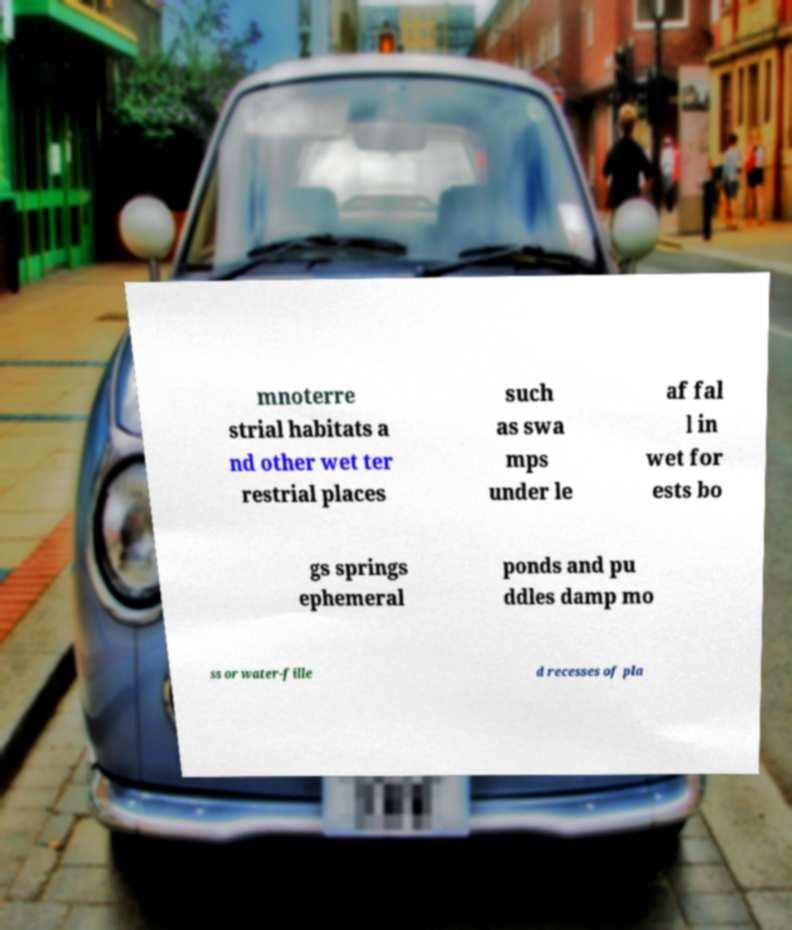Could you extract and type out the text from this image? mnoterre strial habitats a nd other wet ter restrial places such as swa mps under le af fal l in wet for ests bo gs springs ephemeral ponds and pu ddles damp mo ss or water-fille d recesses of pla 